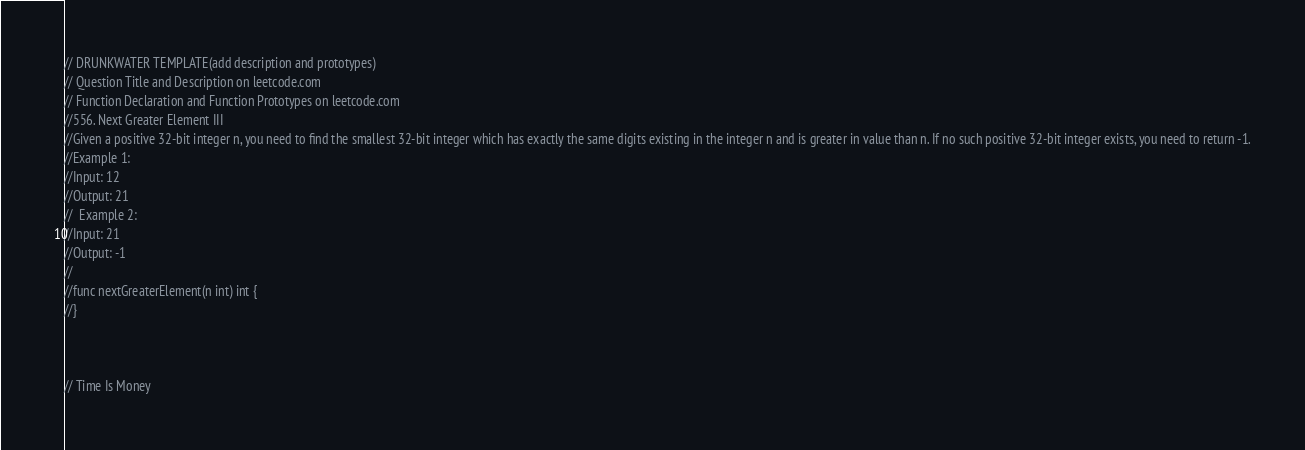<code> <loc_0><loc_0><loc_500><loc_500><_Go_>// DRUNKWATER TEMPLATE(add description and prototypes)
// Question Title and Description on leetcode.com
// Function Declaration and Function Prototypes on leetcode.com
//556. Next Greater Element III
//Given a positive 32-bit integer n, you need to find the smallest 32-bit integer which has exactly the same digits existing in the integer n and is greater in value than n. If no such positive 32-bit integer exists, you need to return -1.
//Example 1:
//Input: 12
//Output: 21
//  Example 2:
//Input: 21
//Output: -1
// 
//func nextGreaterElement(n int) int {
//}



// Time Is Money</code> 